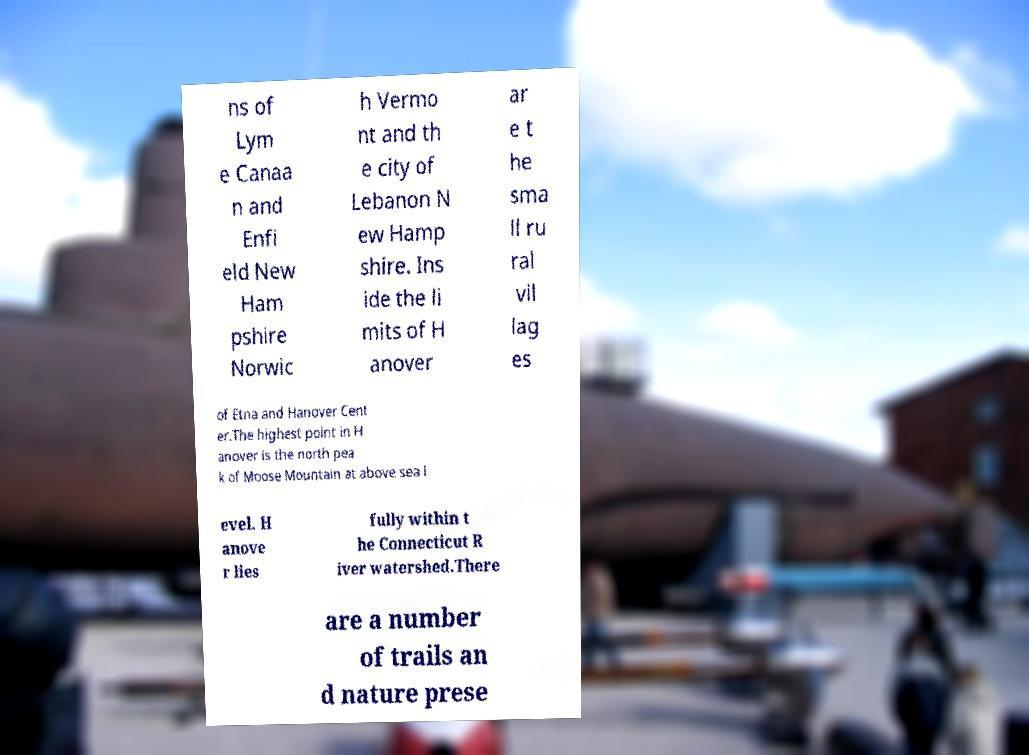Please identify and transcribe the text found in this image. ns of Lym e Canaa n and Enfi eld New Ham pshire Norwic h Vermo nt and th e city of Lebanon N ew Hamp shire. Ins ide the li mits of H anover ar e t he sma ll ru ral vil lag es of Etna and Hanover Cent er.The highest point in H anover is the north pea k of Moose Mountain at above sea l evel. H anove r lies fully within t he Connecticut R iver watershed.There are a number of trails an d nature prese 